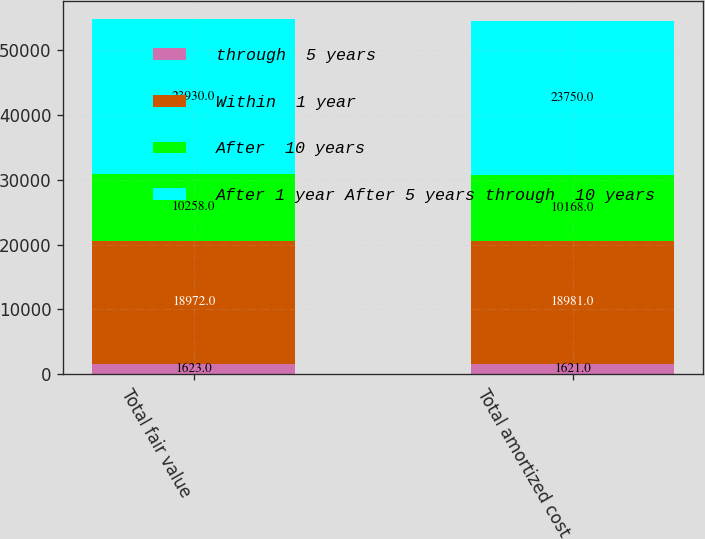<chart> <loc_0><loc_0><loc_500><loc_500><stacked_bar_chart><ecel><fcel>Total fair value<fcel>Total amortized cost<nl><fcel>through  5 years<fcel>1623<fcel>1621<nl><fcel>Within  1 year<fcel>18972<fcel>18981<nl><fcel>After  10 years<fcel>10258<fcel>10168<nl><fcel>After 1 year After 5 years through  10 years<fcel>23930<fcel>23750<nl></chart> 